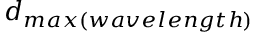Convert formula to latex. <formula><loc_0><loc_0><loc_500><loc_500>d _ { \max ( w a v e l e n g t h ) }</formula> 